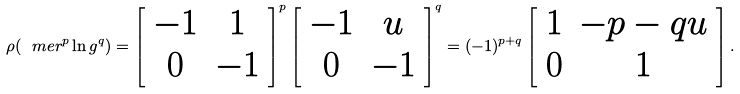Convert formula to latex. <formula><loc_0><loc_0><loc_500><loc_500>\rho ( \ m e r ^ { p } \ln g ^ { q } ) = \left [ \begin{array} { c c } - 1 & 1 \\ 0 & - 1 \end{array} \right ] ^ { p } \left [ \begin{array} { c c } - 1 & u \\ 0 & - 1 \end{array} \right ] ^ { q } = ( - 1 ) ^ { p + q } \left [ \begin{array} { c c } 1 & - p - q u \\ 0 & 1 \end{array} \right ] .</formula> 